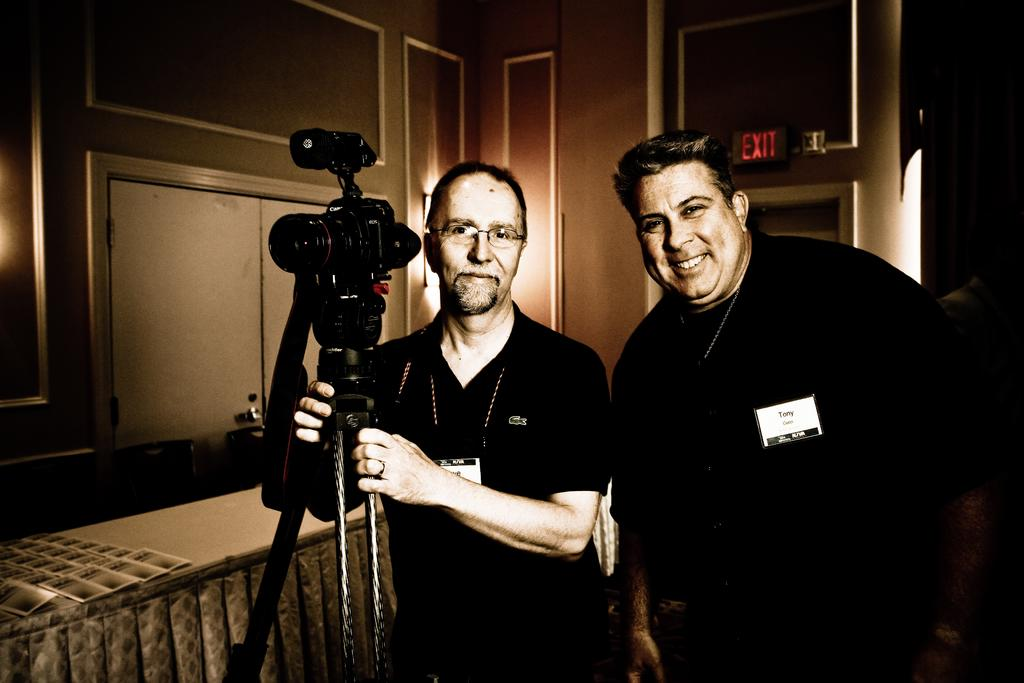What is the man in the middle of the image holding? The man in the middle of the image is holding a camera. Where is the second man located in the image? The second man is on the right side of the image. What expression does the second man have? The second man is smiling. What can be seen in the background of the image? There is an exit board in the background of the image. What advice is the man holding the camera giving to the passenger in the image? There is no passenger present in the image, and the man holding the camera is not giving any advice. 